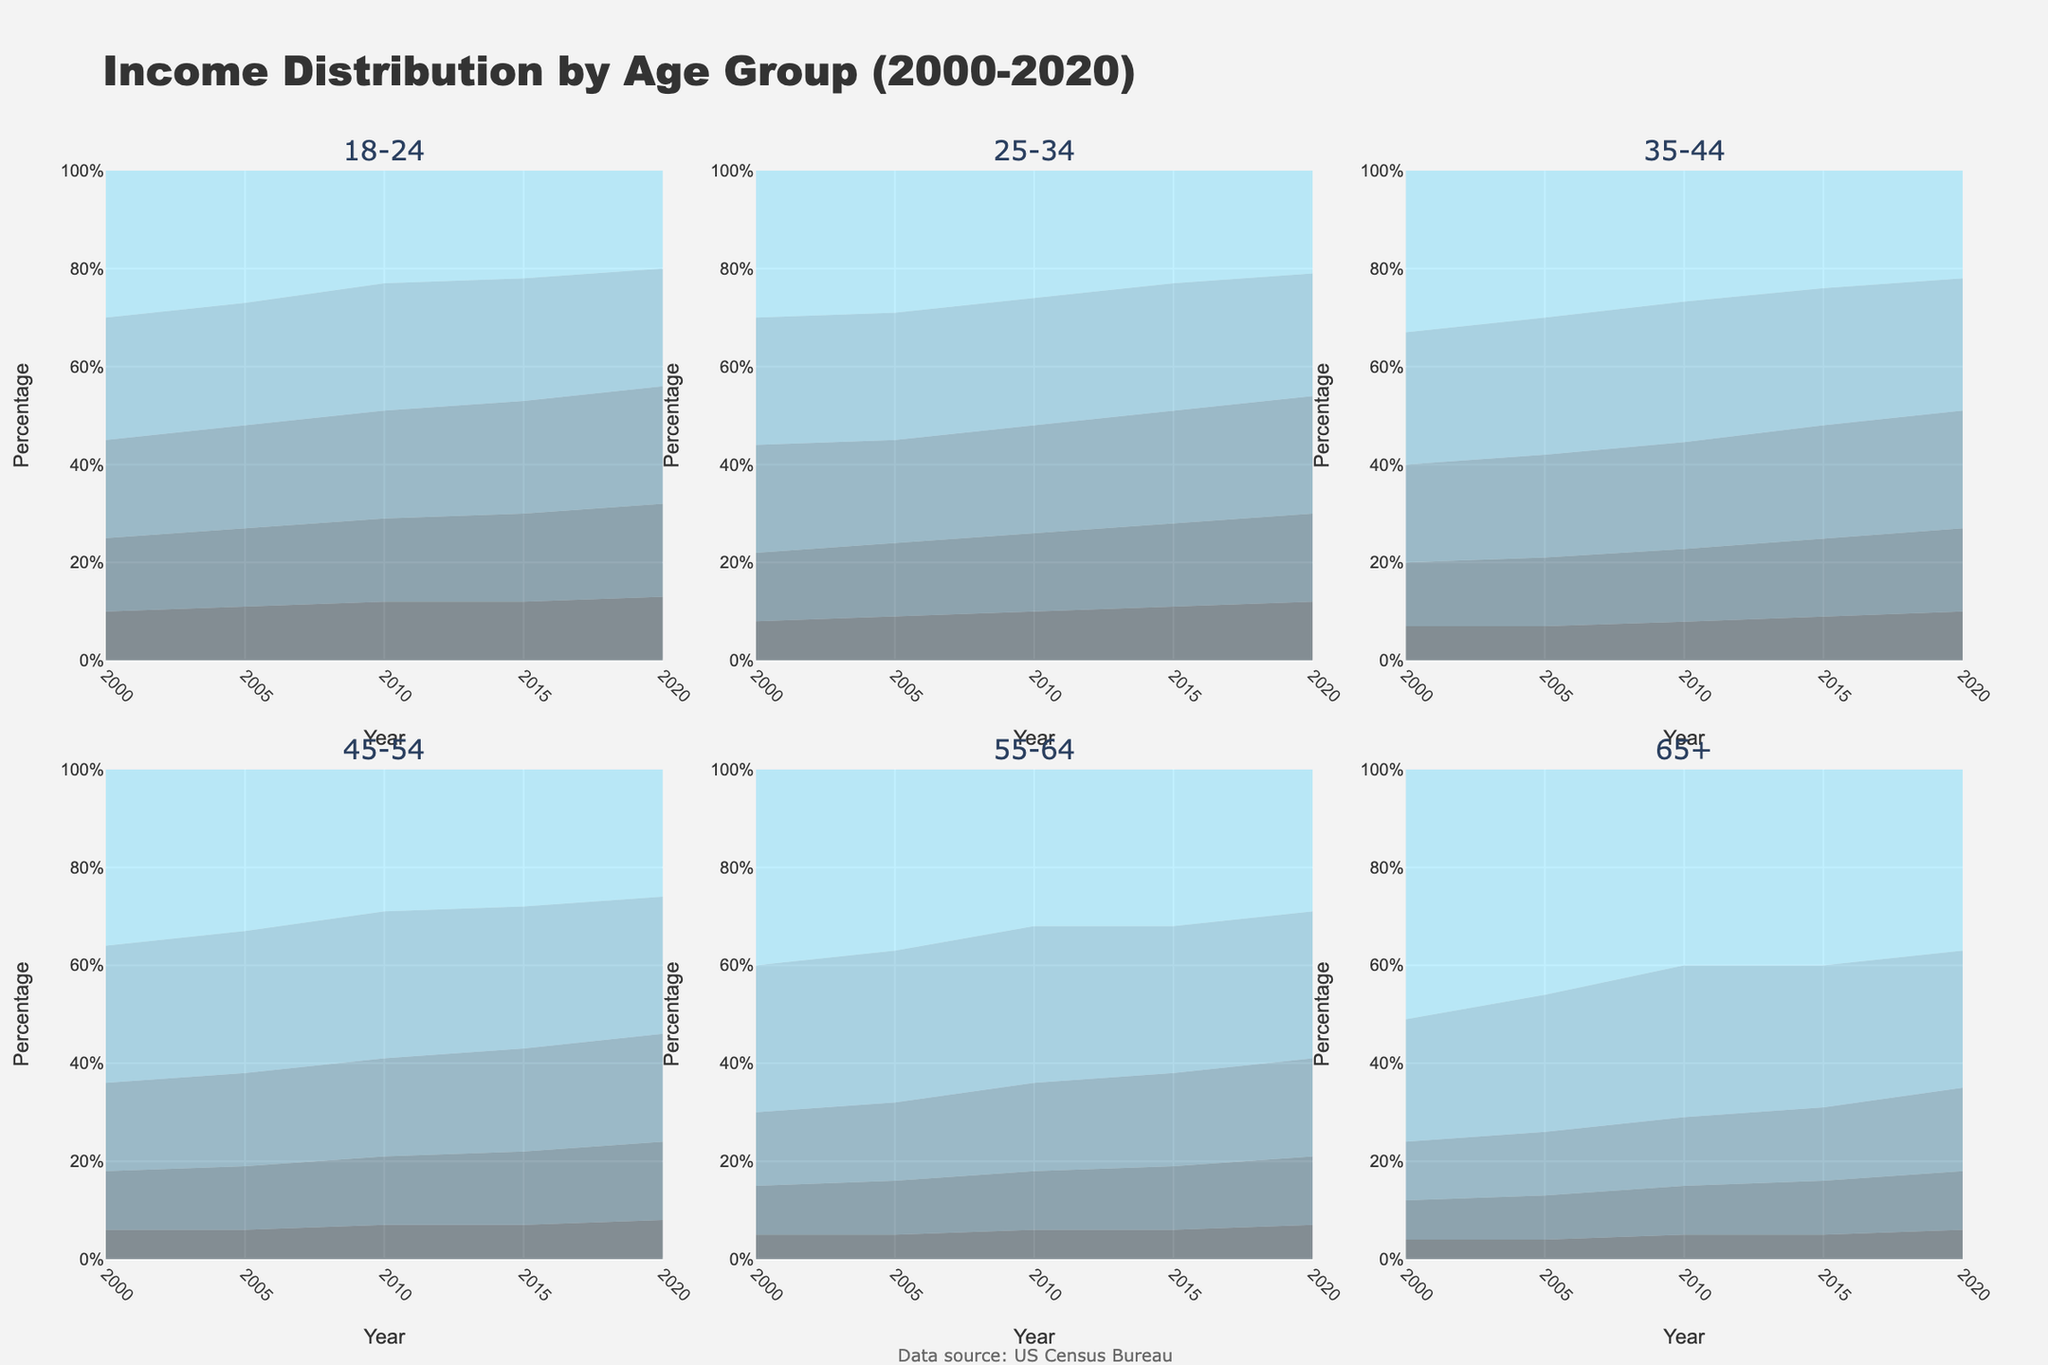What is the title of the chart? The title is located at the top of the figure and is labeled "Income Distribution by Age Group (2000-2020)."
Answer: Income Distribution by Age Group (2000-2020) What does the x-axis represent in each subplot? The x-axis of each subplot shows the years from 2000 to 2020.
Answer: Year How many age groups are represented in the chart? There are six subplots, each titled with an age group, so there are six age groups represented.
Answer: Six Which age group shows the highest percentage for the Top 20% income group in the year 2020? By examining the subplots, the age group 65+ has the highest percentage in the Top 20% category in 2020.
Answer: 65+ In the 2020 subplot for the 25-34 age group, what is the approximate percentage difference between the Middle 20% and the Bottom 20% income groups? The Middle 20% is at approximately 24%, and the Bottom 20% is around 12%, making the difference roughly 24% - 12% = 12%.
Answer: 12% In which years did the 18-24 age group have a higher percentage for the Bottom 20% income group compared to the 25-34 age group? By comparing the data points for the Bottom 20% income group for both age groups across years, years 2010, 2015, and 2020 show higher percentages for the 18-24 age group.
Answer: 2010, 2015, 2020 For the 35-44 age group, how did the percentage of the Second 20% income group change from 2000 to 2020? The Second 20% income group increased from 13% in 2000 to 17% in 2020, a difference of +4%.
Answer: +4% Which two age groups show a decrease in the percentage for the Top 20% income group from 2000 to 2020? Comparing the starting and ending values of the Top 20% income group for all age groups, the 18-24 and 25-34 age groups show a decrease.
Answer: 18-24, 25-34 Is there any age group where the Bottom 20% income group has consistently increased over time? By tracing the Bottom 20% across years for each age group, the 18-24 age group shows a consistent increase.
Answer: 18-24 Between the years 2000 and 2010, which age group showed the most significant percentage increase in the Fourth 20% income group? Comparing the increase in the Fourth 20% between 2000 and 2010 for each age group, the 65+ age group showed the most significant increase from 25% to 31%, a 6% increase.
Answer: 65+ 